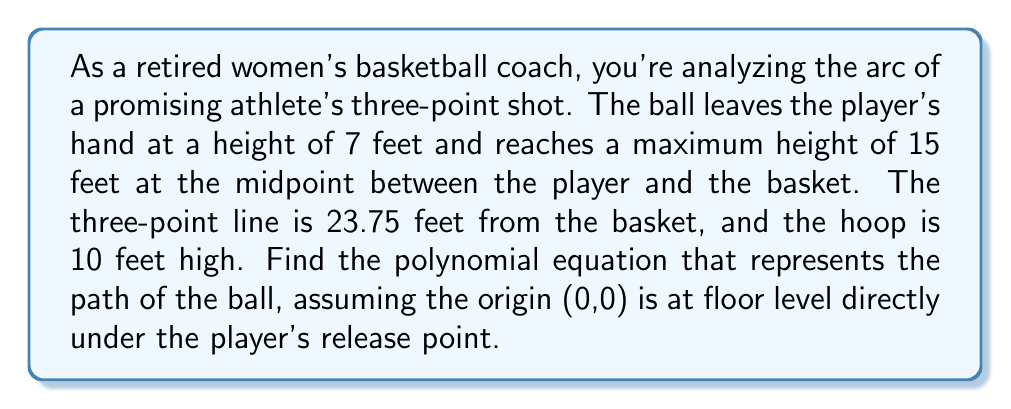Could you help me with this problem? Let's approach this step-by-step:

1) We know the parabola passes through three points:
   (0, 7) - release point
   (11.875, 15) - apex (midpoint of 23.75)
   (23.75, 10) - basket

2) The general form of a quadratic equation is:
   $$ y = ax^2 + bx + c $$

3) Substituting our three points into this equation:
   $$ 7 = a(0)^2 + b(0) + c $$
   $$ 15 = a(11.875)^2 + b(11.875) + c $$
   $$ 10 = a(23.75)^2 + b(23.75) + c $$

4) From the first equation:
   $$ c = 7 $$

5) Subtracting the first equation from the other two:
   $$ 8 = a(11.875)^2 + b(11.875) $$
   $$ 3 = a(23.75)^2 + b(23.75) $$

6) Solving these simultaneously:
   $$ 8 = 140.977a + 11.875b $$
   $$ 3 = 564.063a + 23.75b $$

7) Multiplying the first equation by 2 and subtracting from the second:
   $$ -13 = 282.109a $$
   $$ a = -0.0461 $$

8) Substituting back to find b:
   $$ 8 = 140.977(-0.0461) + 11.875b $$
   $$ b = 0.8721 $$

9) Therefore, the equation is:
   $$ y = -0.0461x^2 + 0.8721x + 7 $$
Answer: $$ y = -0.0461x^2 + 0.8721x + 7 $$ 